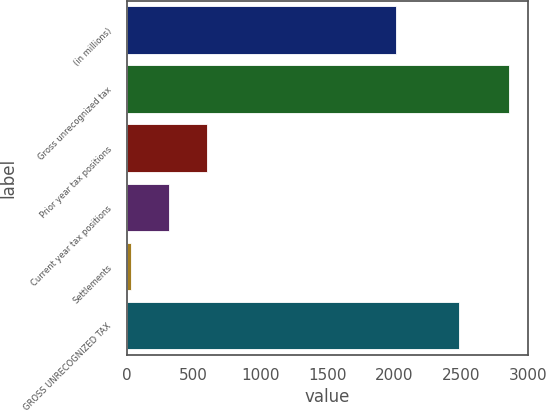Convert chart. <chart><loc_0><loc_0><loc_500><loc_500><bar_chart><fcel>(in millions)<fcel>Gross unrecognized tax<fcel>Prior year tax positions<fcel>Current year tax positions<fcel>Settlements<fcel>GROSS UNRECOGNIZED TAX<nl><fcel>2015<fcel>2860<fcel>598.4<fcel>315.7<fcel>33<fcel>2482<nl></chart> 